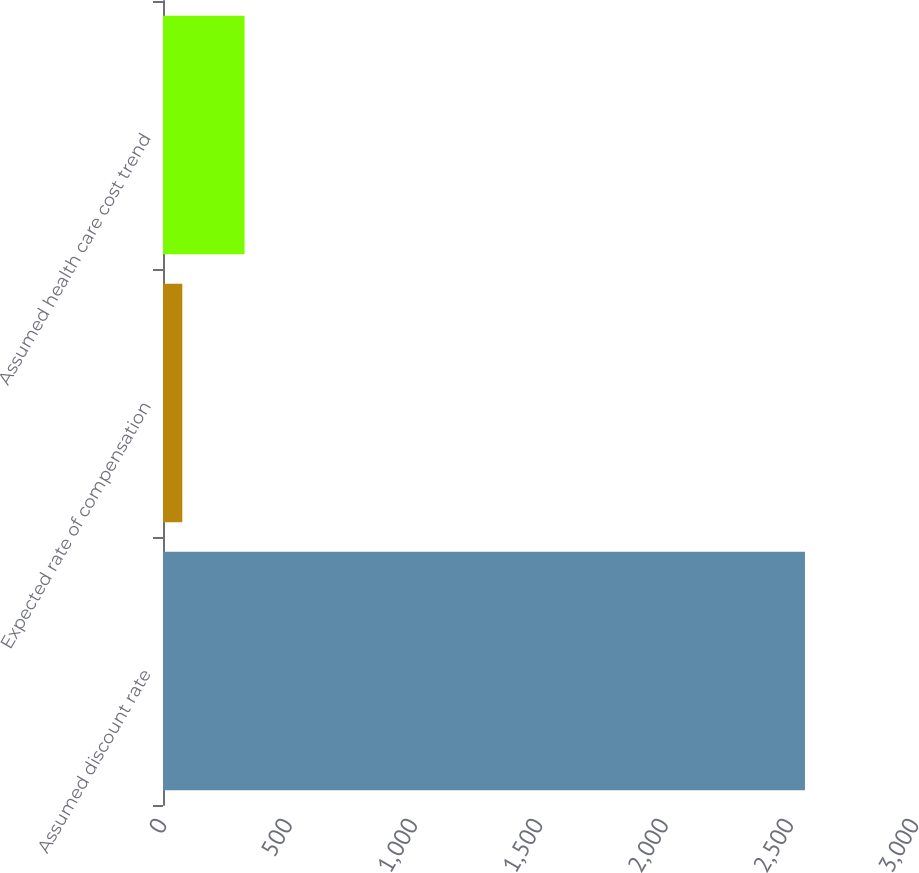Convert chart to OTSL. <chart><loc_0><loc_0><loc_500><loc_500><bar_chart><fcel>Assumed discount rate<fcel>Expected rate of compensation<fcel>Assumed health care cost trend<nl><fcel>2561<fcel>77<fcel>325.4<nl></chart> 